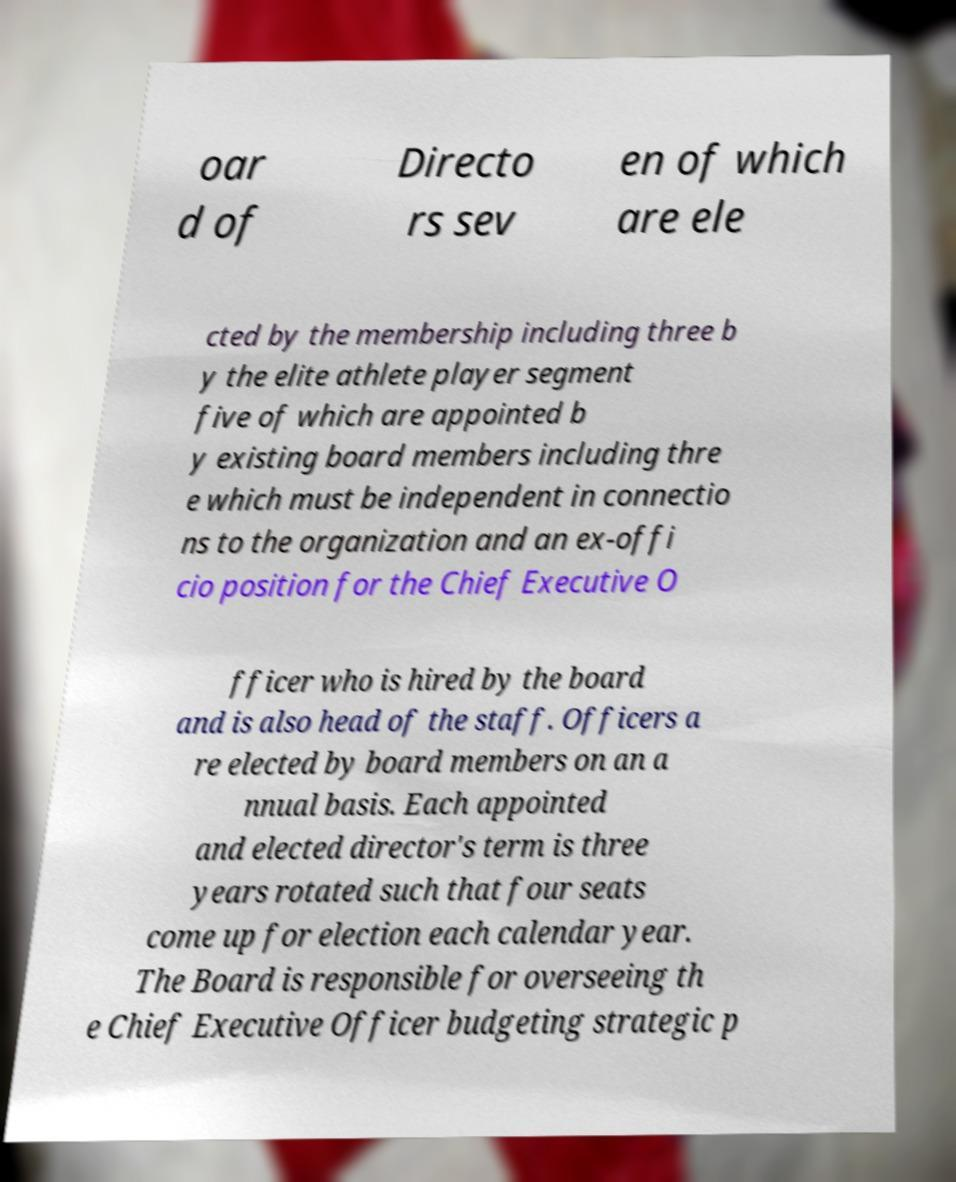I need the written content from this picture converted into text. Can you do that? oar d of Directo rs sev en of which are ele cted by the membership including three b y the elite athlete player segment five of which are appointed b y existing board members including thre e which must be independent in connectio ns to the organization and an ex-offi cio position for the Chief Executive O fficer who is hired by the board and is also head of the staff. Officers a re elected by board members on an a nnual basis. Each appointed and elected director's term is three years rotated such that four seats come up for election each calendar year. The Board is responsible for overseeing th e Chief Executive Officer budgeting strategic p 